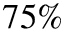Convert formula to latex. <formula><loc_0><loc_0><loc_500><loc_500>7 5 \%</formula> 